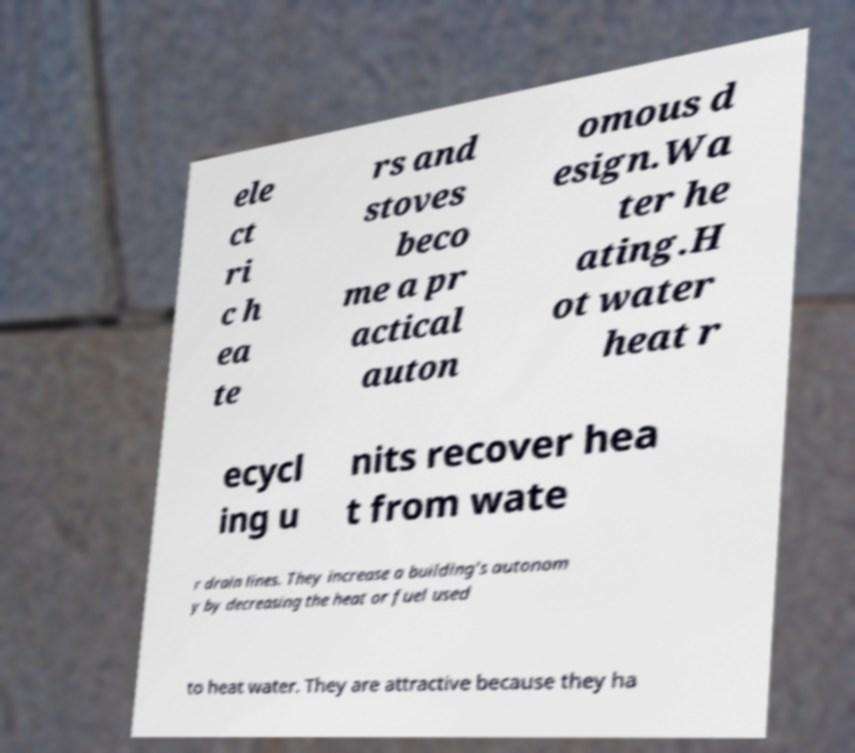Could you extract and type out the text from this image? ele ct ri c h ea te rs and stoves beco me a pr actical auton omous d esign.Wa ter he ating.H ot water heat r ecycl ing u nits recover hea t from wate r drain lines. They increase a building's autonom y by decreasing the heat or fuel used to heat water. They are attractive because they ha 